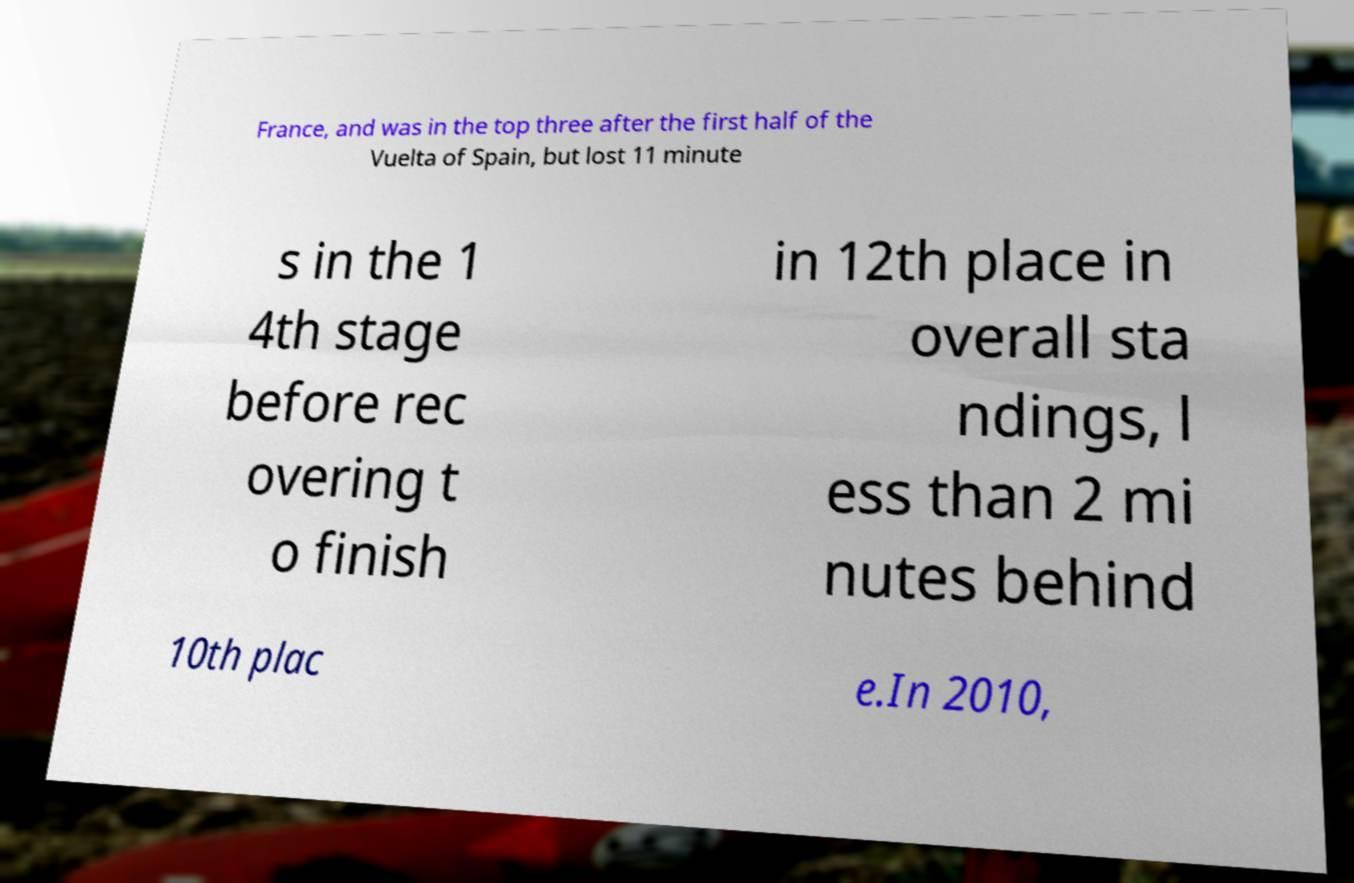Can you read and provide the text displayed in the image?This photo seems to have some interesting text. Can you extract and type it out for me? France, and was in the top three after the first half of the Vuelta of Spain, but lost 11 minute s in the 1 4th stage before rec overing t o finish in 12th place in overall sta ndings, l ess than 2 mi nutes behind 10th plac e.In 2010, 